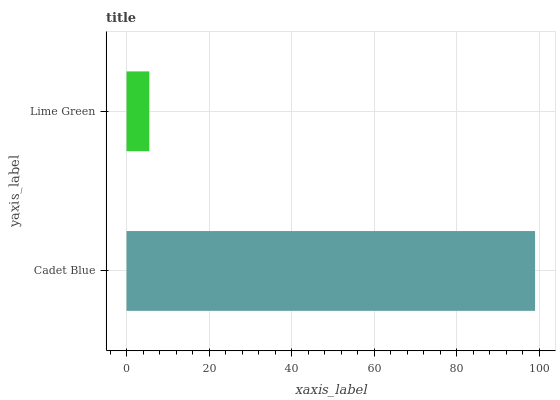Is Lime Green the minimum?
Answer yes or no. Yes. Is Cadet Blue the maximum?
Answer yes or no. Yes. Is Lime Green the maximum?
Answer yes or no. No. Is Cadet Blue greater than Lime Green?
Answer yes or no. Yes. Is Lime Green less than Cadet Blue?
Answer yes or no. Yes. Is Lime Green greater than Cadet Blue?
Answer yes or no. No. Is Cadet Blue less than Lime Green?
Answer yes or no. No. Is Cadet Blue the high median?
Answer yes or no. Yes. Is Lime Green the low median?
Answer yes or no. Yes. Is Lime Green the high median?
Answer yes or no. No. Is Cadet Blue the low median?
Answer yes or no. No. 